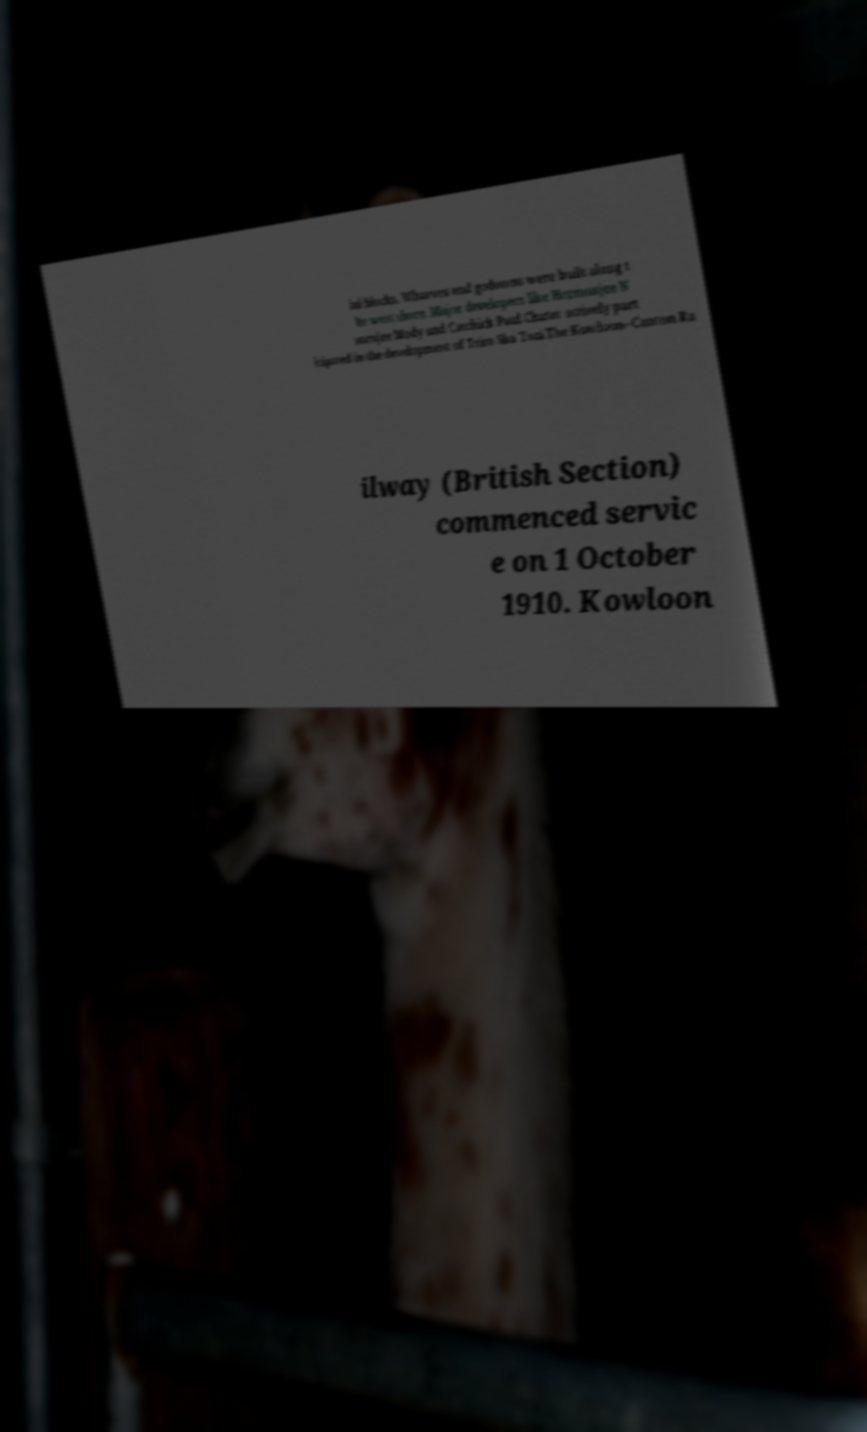Please identify and transcribe the text found in this image. ial blocks. Wharves and godowns were built along t he west shore. Major developers like Hormusjee N aorojee Mody and Catchick Paul Chater actively part icipated in the development of Tsim Sha Tsui.The Kowloon–Canton Ra ilway (British Section) commenced servic e on 1 October 1910. Kowloon 